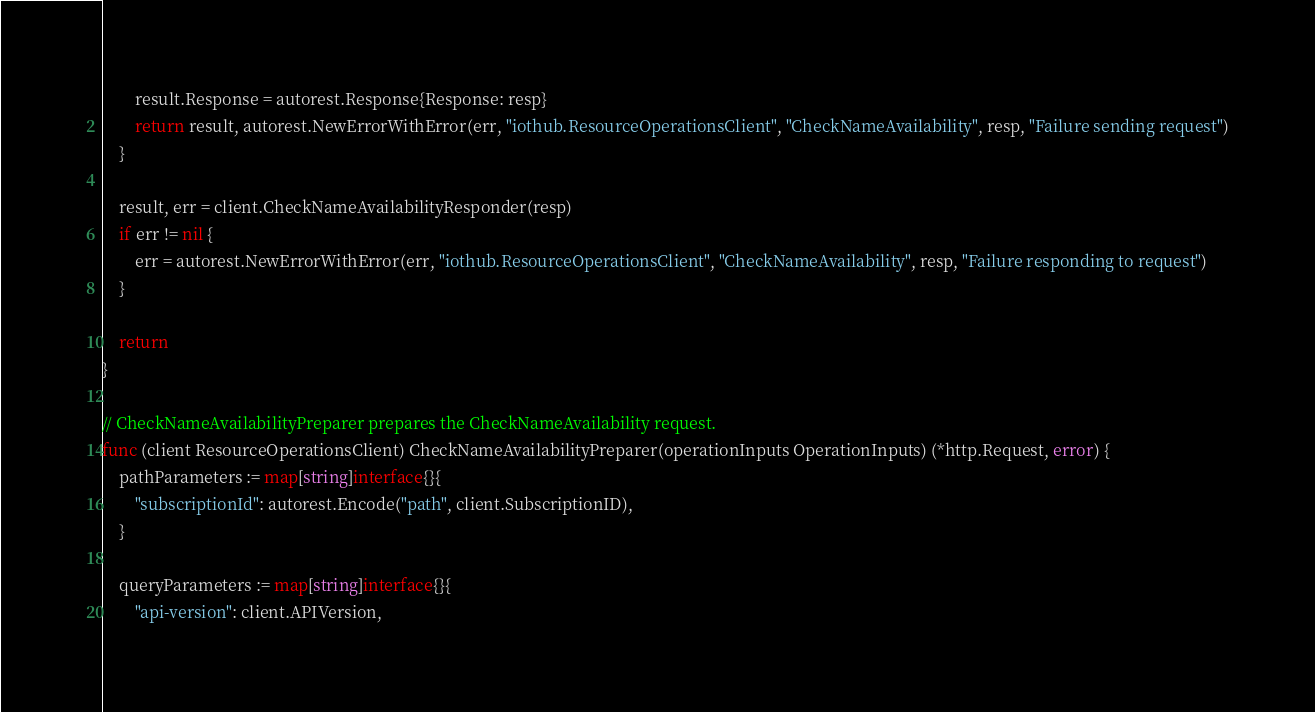Convert code to text. <code><loc_0><loc_0><loc_500><loc_500><_Go_>		result.Response = autorest.Response{Response: resp}
		return result, autorest.NewErrorWithError(err, "iothub.ResourceOperationsClient", "CheckNameAvailability", resp, "Failure sending request")
	}

	result, err = client.CheckNameAvailabilityResponder(resp)
	if err != nil {
		err = autorest.NewErrorWithError(err, "iothub.ResourceOperationsClient", "CheckNameAvailability", resp, "Failure responding to request")
	}

	return
}

// CheckNameAvailabilityPreparer prepares the CheckNameAvailability request.
func (client ResourceOperationsClient) CheckNameAvailabilityPreparer(operationInputs OperationInputs) (*http.Request, error) {
	pathParameters := map[string]interface{}{
		"subscriptionId": autorest.Encode("path", client.SubscriptionID),
	}

	queryParameters := map[string]interface{}{
		"api-version": client.APIVersion,</code> 